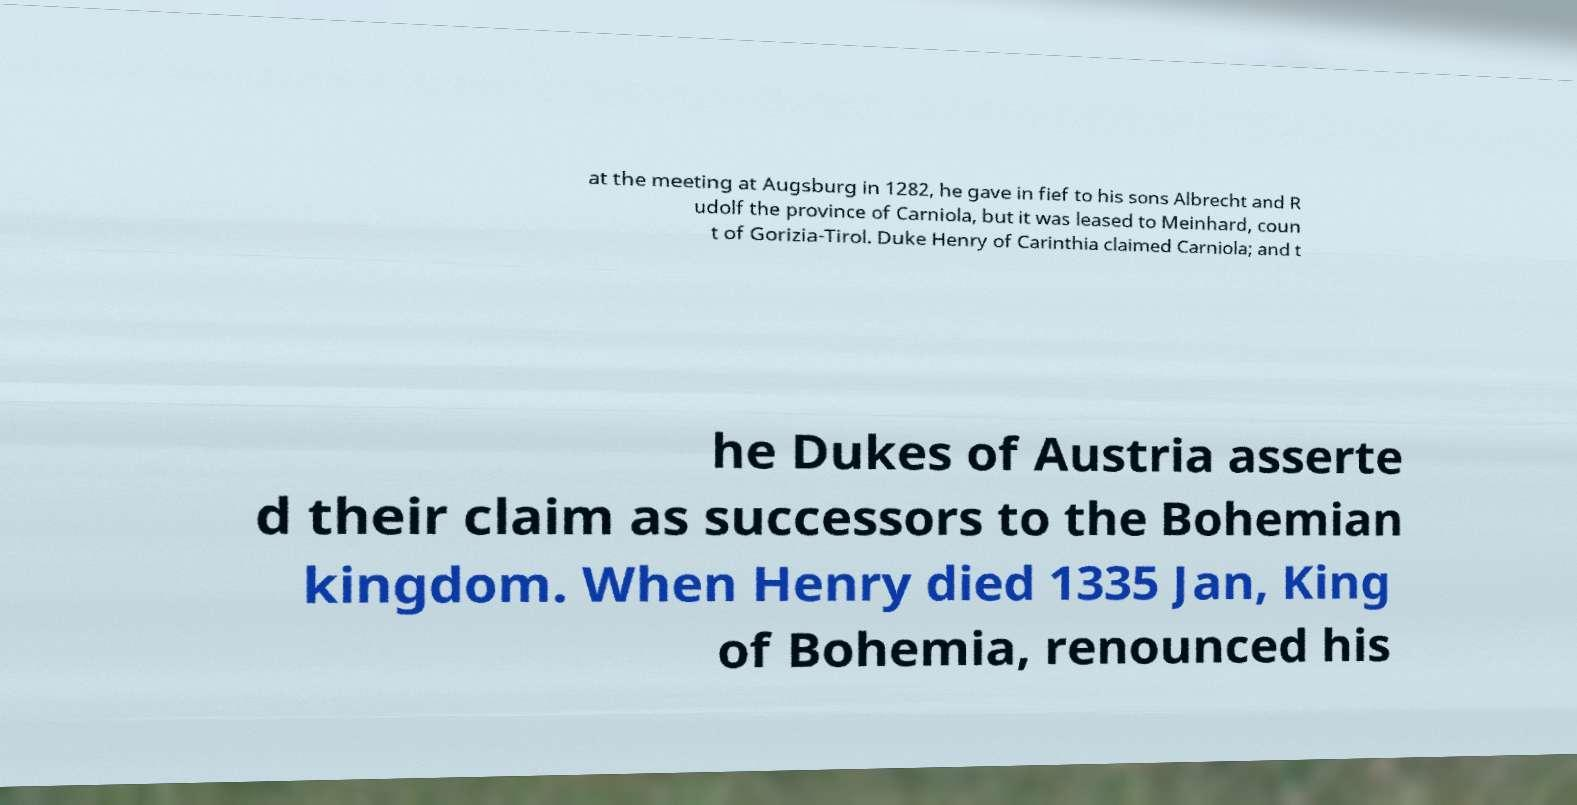Please read and relay the text visible in this image. What does it say? at the meeting at Augsburg in 1282, he gave in fief to his sons Albrecht and R udolf the province of Carniola, but it was leased to Meinhard, coun t of Gorizia-Tirol. Duke Henry of Carinthia claimed Carniola; and t he Dukes of Austria asserte d their claim as successors to the Bohemian kingdom. When Henry died 1335 Jan, King of Bohemia, renounced his 